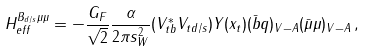Convert formula to latex. <formula><loc_0><loc_0><loc_500><loc_500>H _ { e f f } ^ { B _ { d / s } \mu \mu } = - \frac { G _ { F } } { \sqrt { 2 } } \frac { \alpha } { 2 \pi s _ { W } ^ { 2 } } ( V ^ { * } _ { t b } V _ { t d / s } ) Y ( x _ { t } ) ( \bar { b } q ) _ { V - A } ( \bar { \mu } \mu ) _ { V - A } \, ,</formula> 